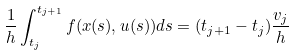Convert formula to latex. <formula><loc_0><loc_0><loc_500><loc_500>\frac { 1 } { h } \int _ { t _ { j } } ^ { t _ { j + 1 } } f ( x ( s ) , u ( s ) ) d s = ( t _ { j + 1 } - t _ { j } ) \frac { v _ { j } } { h }</formula> 